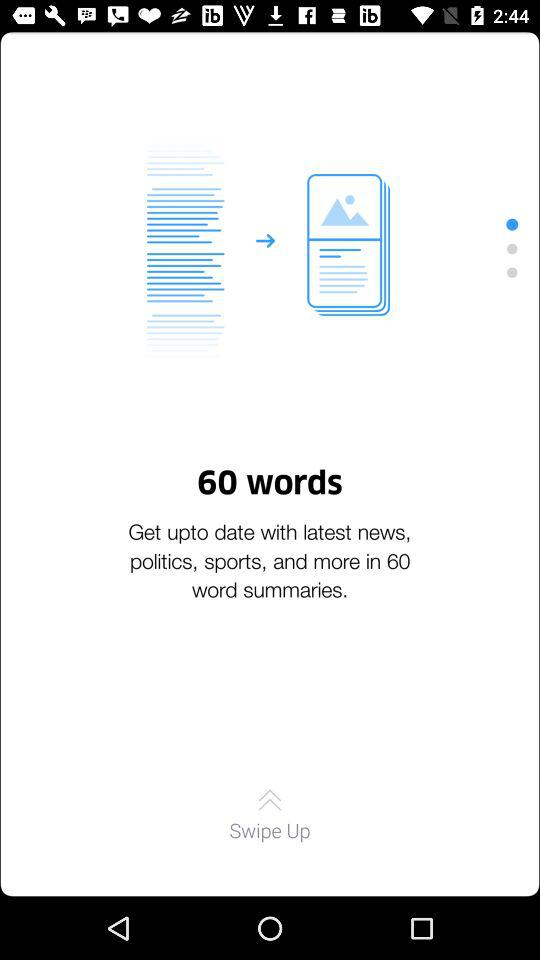How many words are there in word summaries? There are 60 words. 